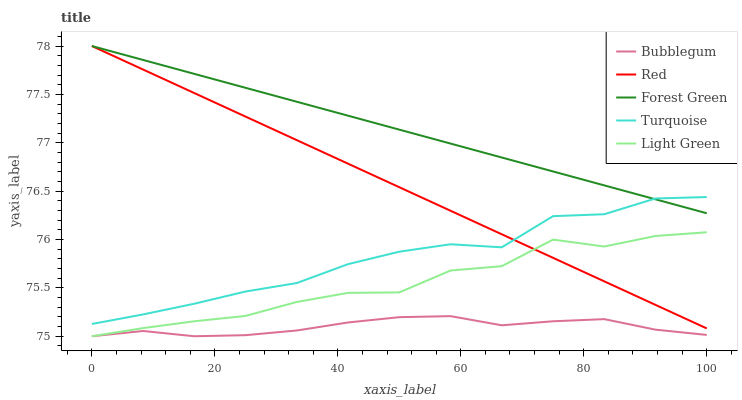Does Bubblegum have the minimum area under the curve?
Answer yes or no. Yes. Does Forest Green have the maximum area under the curve?
Answer yes or no. Yes. Does Turquoise have the minimum area under the curve?
Answer yes or no. No. Does Turquoise have the maximum area under the curve?
Answer yes or no. No. Is Red the smoothest?
Answer yes or no. Yes. Is Light Green the roughest?
Answer yes or no. Yes. Is Forest Green the smoothest?
Answer yes or no. No. Is Forest Green the roughest?
Answer yes or no. No. Does Turquoise have the lowest value?
Answer yes or no. No. Does Turquoise have the highest value?
Answer yes or no. No. Is Bubblegum less than Forest Green?
Answer yes or no. Yes. Is Forest Green greater than Light Green?
Answer yes or no. Yes. Does Bubblegum intersect Forest Green?
Answer yes or no. No. 